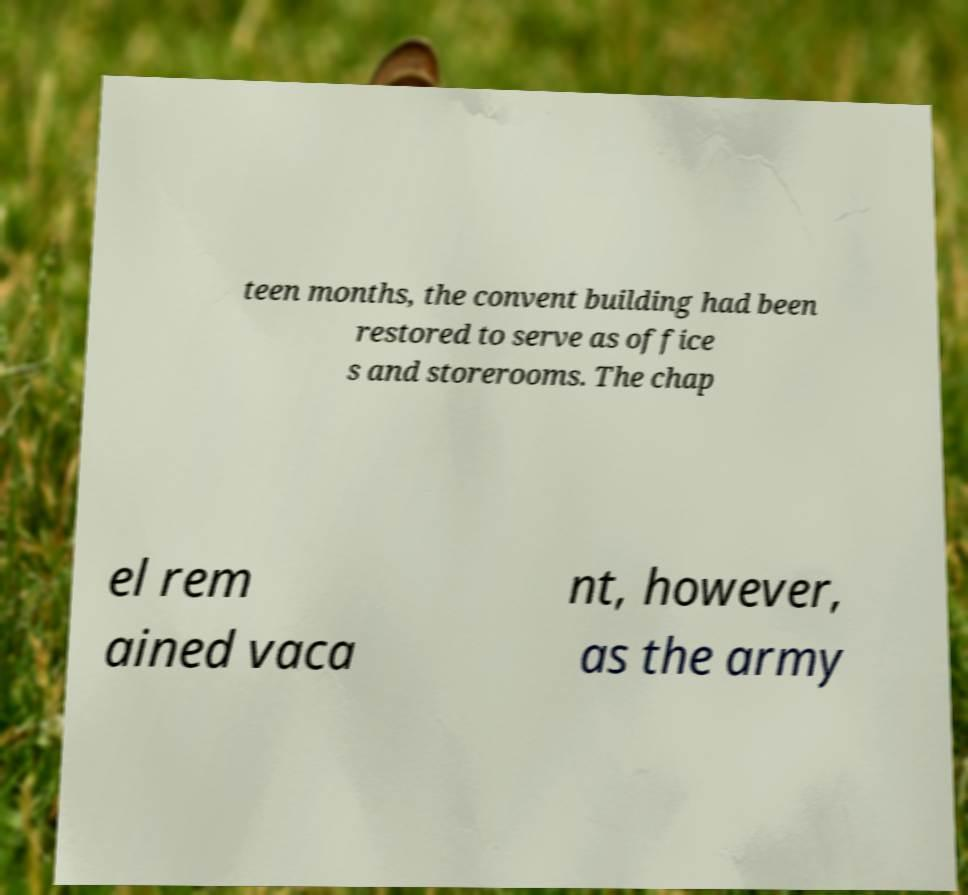For documentation purposes, I need the text within this image transcribed. Could you provide that? teen months, the convent building had been restored to serve as office s and storerooms. The chap el rem ained vaca nt, however, as the army 